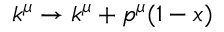<formula> <loc_0><loc_0><loc_500><loc_500>k ^ { \mu } \rightarrow k ^ { \mu } + p ^ { \mu } ( 1 - x )</formula> 